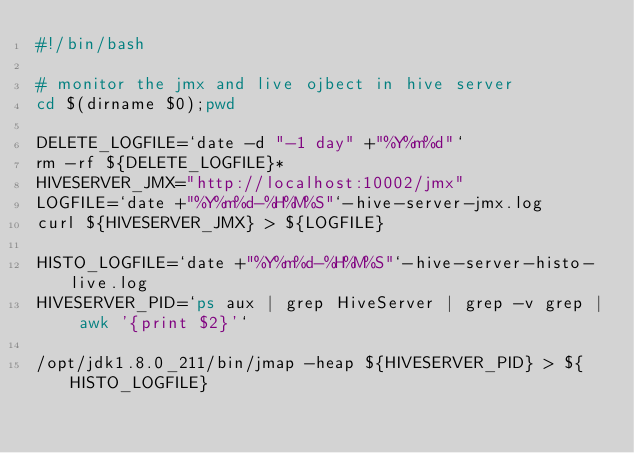Convert code to text. <code><loc_0><loc_0><loc_500><loc_500><_Bash_>#!/bin/bash

# monitor the jmx and live ojbect in hive server
cd $(dirname $0);pwd

DELETE_LOGFILE=`date -d "-1 day" +"%Y%m%d"`
rm -rf ${DELETE_LOGFILE}*
HIVESERVER_JMX="http://localhost:10002/jmx"
LOGFILE=`date +"%Y%m%d-%H%M%S"`-hive-server-jmx.log
curl ${HIVESERVER_JMX} > ${LOGFILE}

HISTO_LOGFILE=`date +"%Y%m%d-%H%M%S"`-hive-server-histo-live.log
HIVESERVER_PID=`ps aux | grep HiveServer | grep -v grep | awk '{print $2}'`

/opt/jdk1.8.0_211/bin/jmap -heap ${HIVESERVER_PID} > ${HISTO_LOGFILE}
</code> 